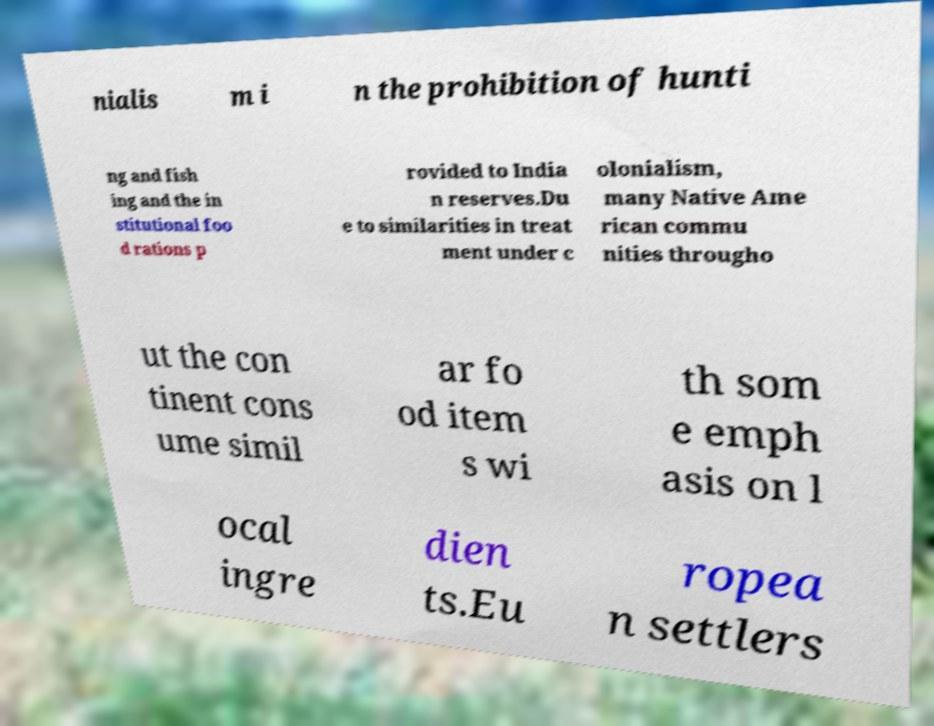What messages or text are displayed in this image? I need them in a readable, typed format. nialis m i n the prohibition of hunti ng and fish ing and the in stitutional foo d rations p rovided to India n reserves.Du e to similarities in treat ment under c olonialism, many Native Ame rican commu nities througho ut the con tinent cons ume simil ar fo od item s wi th som e emph asis on l ocal ingre dien ts.Eu ropea n settlers 